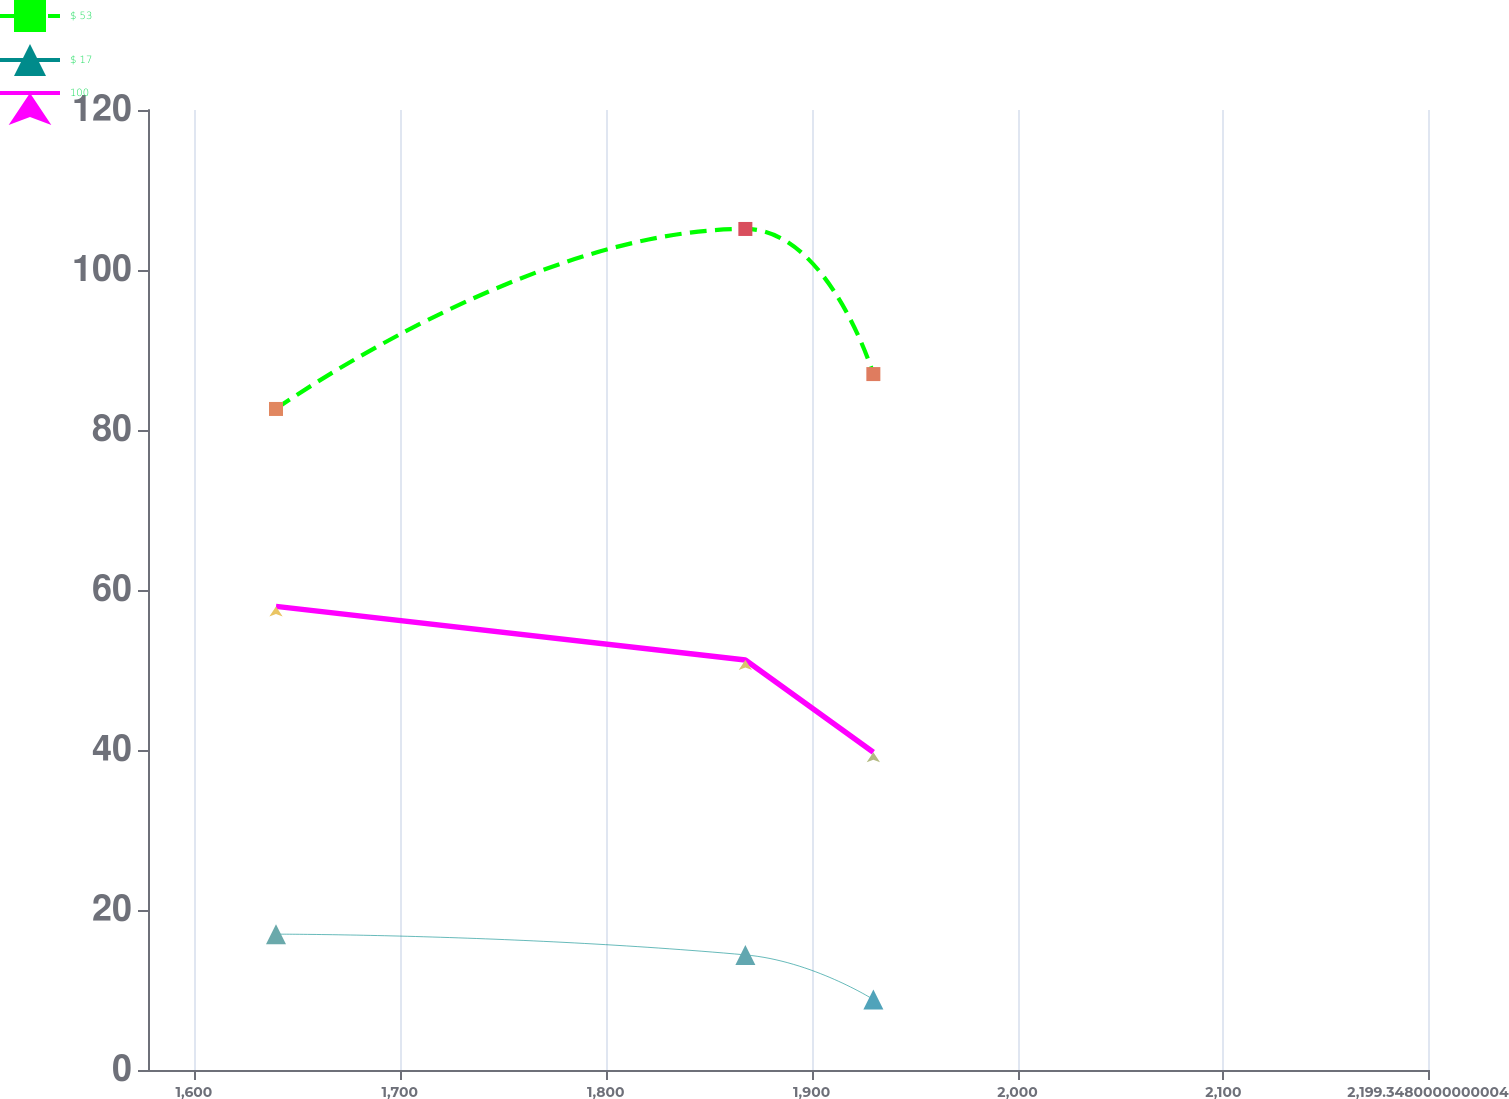Convert chart. <chart><loc_0><loc_0><loc_500><loc_500><line_chart><ecel><fcel>$ 53<fcel>$ 17<fcel>100<nl><fcel>1639.89<fcel>82.63<fcel>16.98<fcel>57.95<nl><fcel>1867.83<fcel>105.13<fcel>14.39<fcel>51.25<nl><fcel>1929.99<fcel>86.99<fcel>8.81<fcel>39.72<nl><fcel>2261.51<fcel>75.4<fcel>9.63<fcel>41.7<nl></chart> 